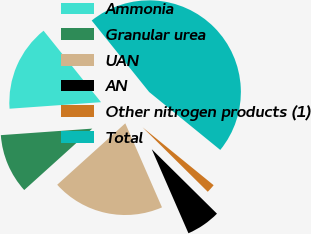Convert chart. <chart><loc_0><loc_0><loc_500><loc_500><pie_chart><fcel>Ammonia<fcel>Granular urea<fcel>UAN<fcel>AN<fcel>Other nitrogen products (1)<fcel>Total<nl><fcel>15.36%<fcel>10.55%<fcel>19.87%<fcel>6.04%<fcel>1.53%<fcel>46.66%<nl></chart> 